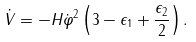<formula> <loc_0><loc_0><loc_500><loc_500>\dot { V } = - H \dot { \varphi } ^ { 2 } \left ( 3 - \epsilon _ { 1 } + \frac { \epsilon _ { 2 } } { 2 } \right ) .</formula> 